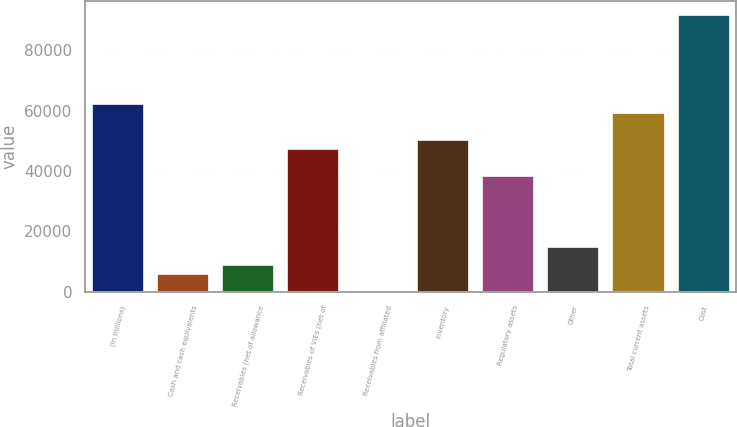Convert chart. <chart><loc_0><loc_0><loc_500><loc_500><bar_chart><fcel>(in millions)<fcel>Cash and cash equivalents<fcel>Receivables (net of allowance<fcel>Receivables of VIEs (net of<fcel>Receivables from affiliated<fcel>Inventory<fcel>Regulatory assets<fcel>Other<fcel>Total current assets<fcel>Cost<nl><fcel>62121<fcel>5919<fcel>8877<fcel>47331<fcel>3<fcel>50289<fcel>38457<fcel>14793<fcel>59163<fcel>91701<nl></chart> 